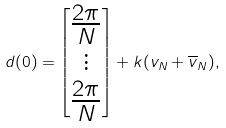Convert formula to latex. <formula><loc_0><loc_0><loc_500><loc_500>d ( 0 ) = \begin{bmatrix} \frac { 2 \pi } { N } \\ \vdots \\ \frac { 2 \pi } { N } \end{bmatrix} + k ( v _ { N } + \overline { v } _ { N } ) ,</formula> 